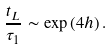Convert formula to latex. <formula><loc_0><loc_0><loc_500><loc_500>\frac { t _ { L } } { \tau _ { 1 } } \sim \exp \left ( 4 h \right ) .</formula> 